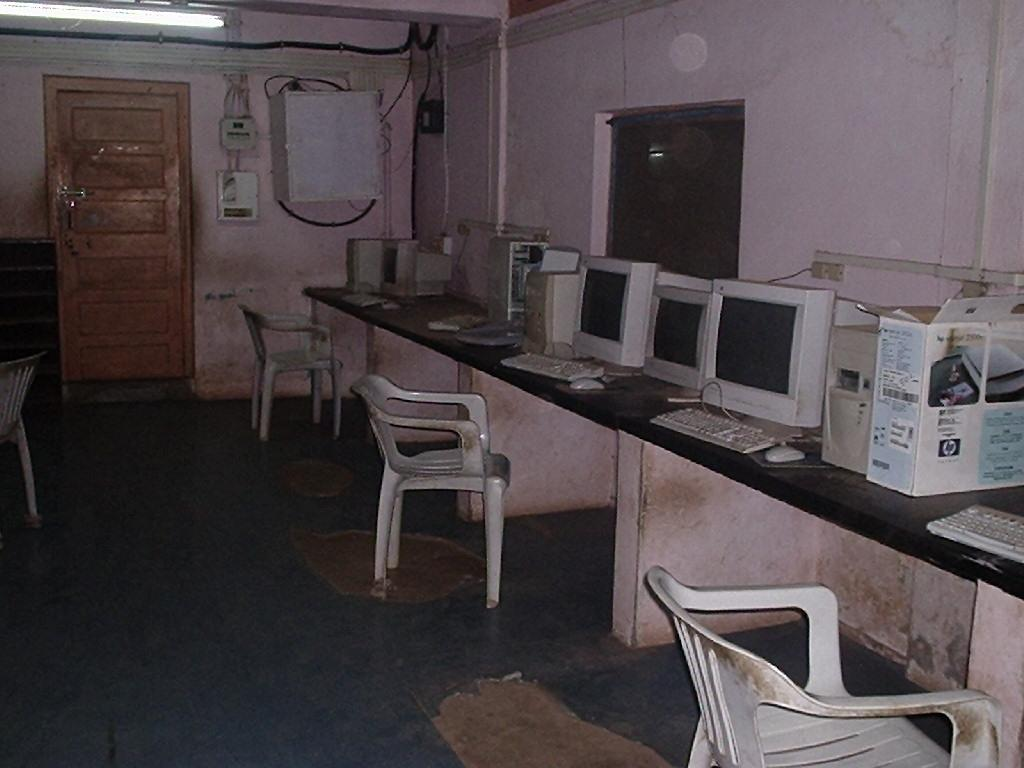What type of electronic devices are present in the image? There are monitors, keyboards, and mouses in the image. What type of furniture is in the image? There are chairs in the image. What architectural feature can be seen in the image? There is a door in the image. What type of illumination is visible in the image? There is light visible in the image. What additional object can be seen in the image? There is a box in the image. What type of mint is growing on the roof in the image? There is no roof or mint present in the image. What rule is being enforced by the objects in the image? There is no rule being enforced by the objects in the image; they are simply electronic devices and furniture. 